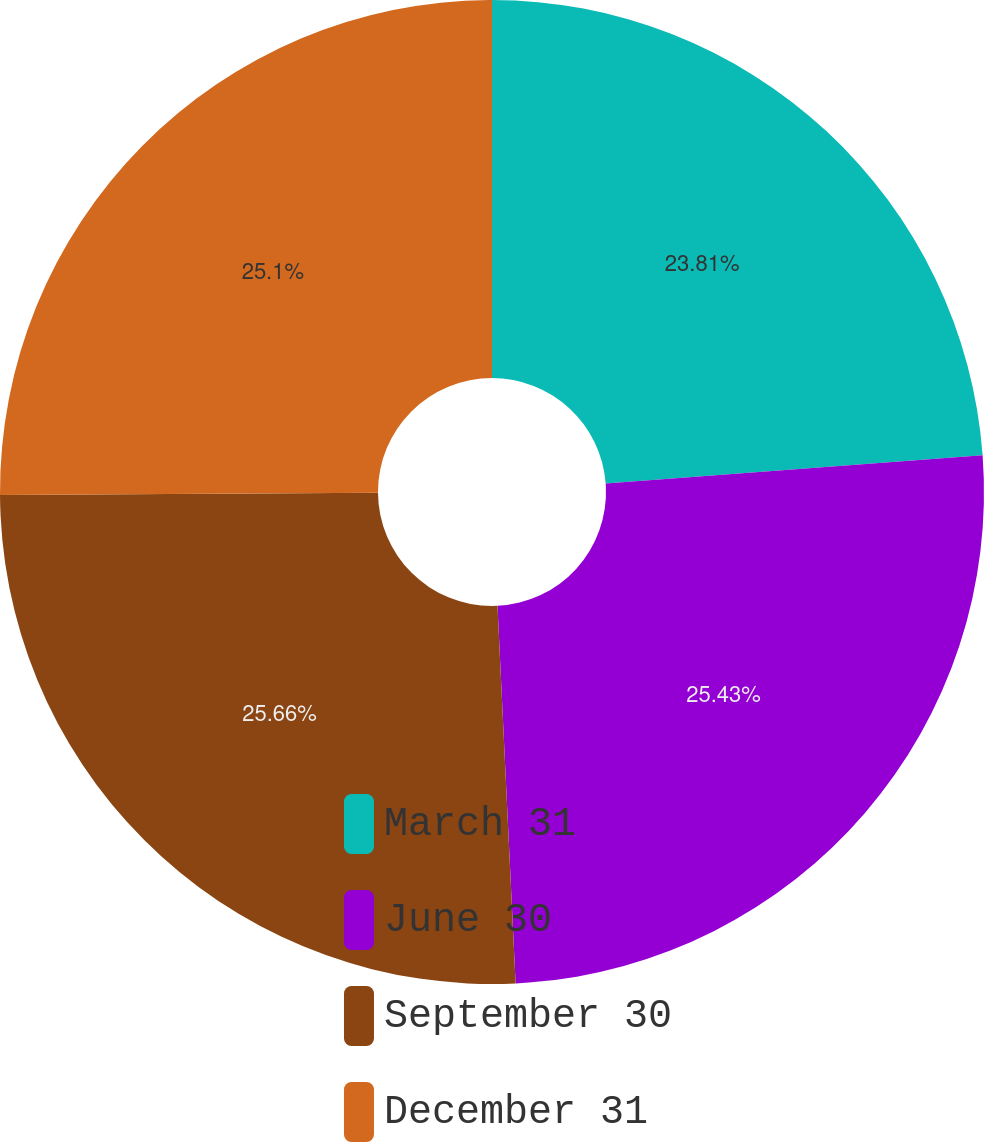Convert chart. <chart><loc_0><loc_0><loc_500><loc_500><pie_chart><fcel>March 31<fcel>June 30<fcel>September 30<fcel>December 31<nl><fcel>23.81%<fcel>25.43%<fcel>25.67%<fcel>25.1%<nl></chart> 